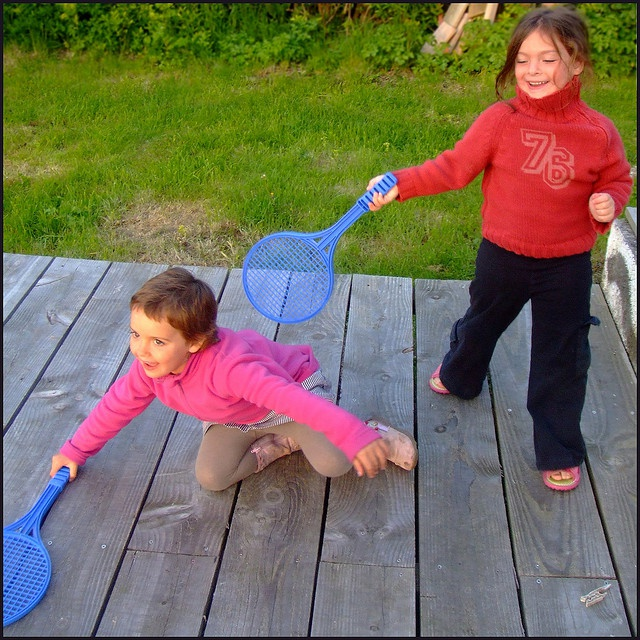Describe the objects in this image and their specific colors. I can see people in black, brown, and salmon tones, people in black, violet, gray, darkgray, and maroon tones, tennis racket in black, lightblue, blue, and gray tones, and tennis racket in black, lightblue, and blue tones in this image. 